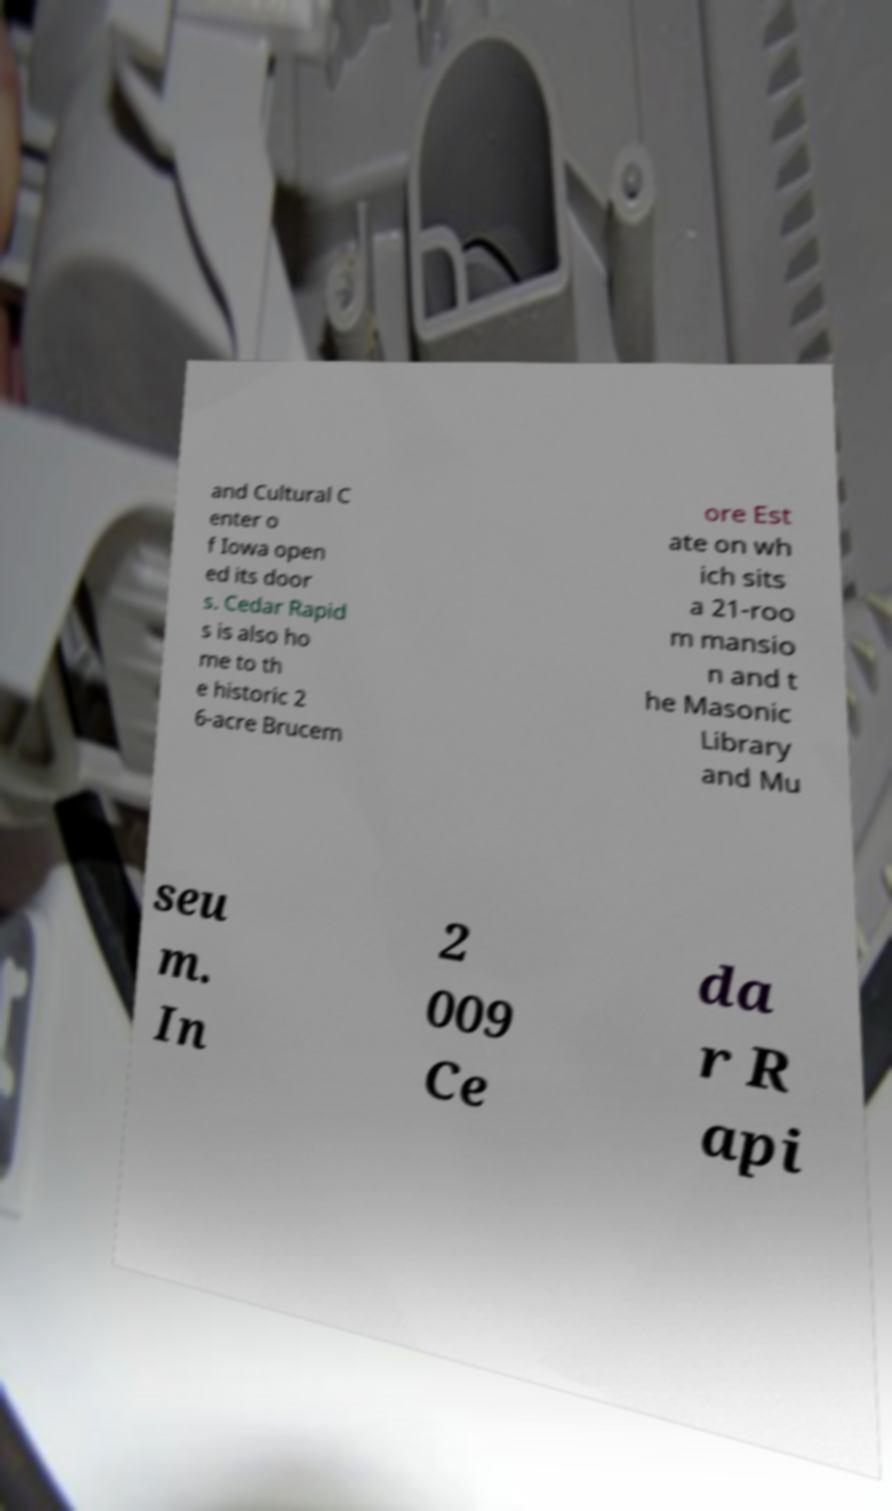For documentation purposes, I need the text within this image transcribed. Could you provide that? and Cultural C enter o f Iowa open ed its door s. Cedar Rapid s is also ho me to th e historic 2 6-acre Brucem ore Est ate on wh ich sits a 21-roo m mansio n and t he Masonic Library and Mu seu m. In 2 009 Ce da r R api 